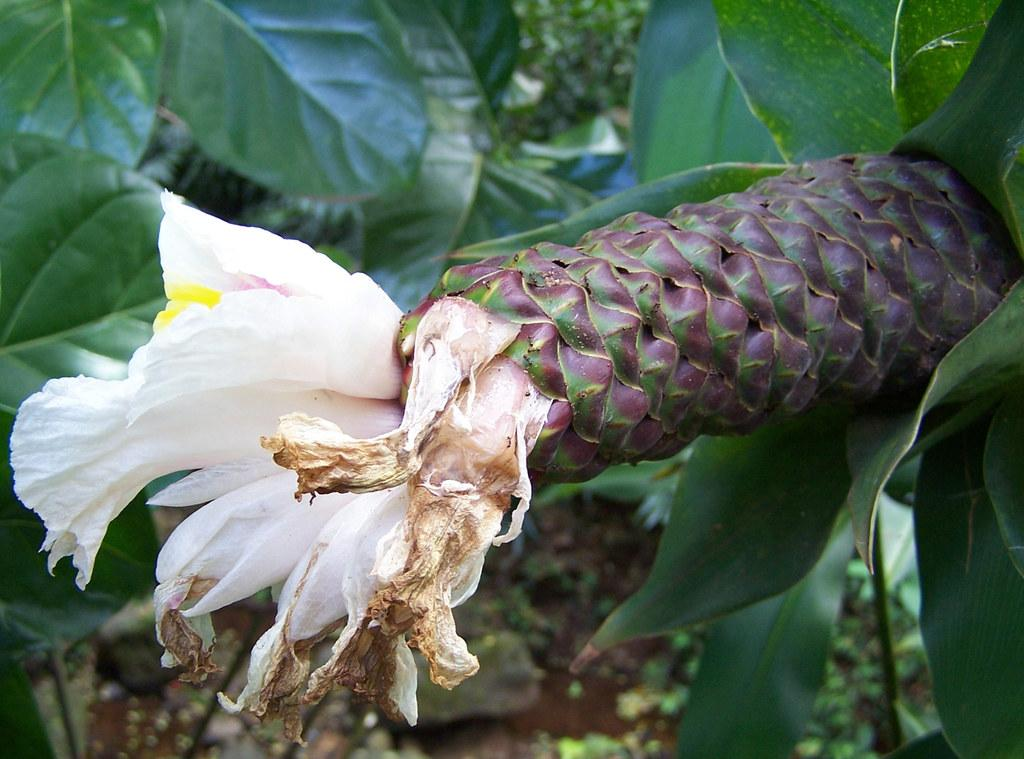What is the main subject of the image? There is a flower in the image. Can you describe the colors of the flower? The flower has white and yellow colors. What can be seen in the background of the image? There are plants in the background of the image. What color are the plants in the background? The plants have a green color. What is the rate of furniture production in the image? There is no furniture present in the image, so it is not possible to determine the rate of furniture production. 